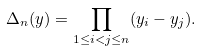<formula> <loc_0><loc_0><loc_500><loc_500>\Delta _ { n } ( y ) = \prod _ { 1 \leq i < j \leq n } ( y _ { i } - y _ { j } ) .</formula> 